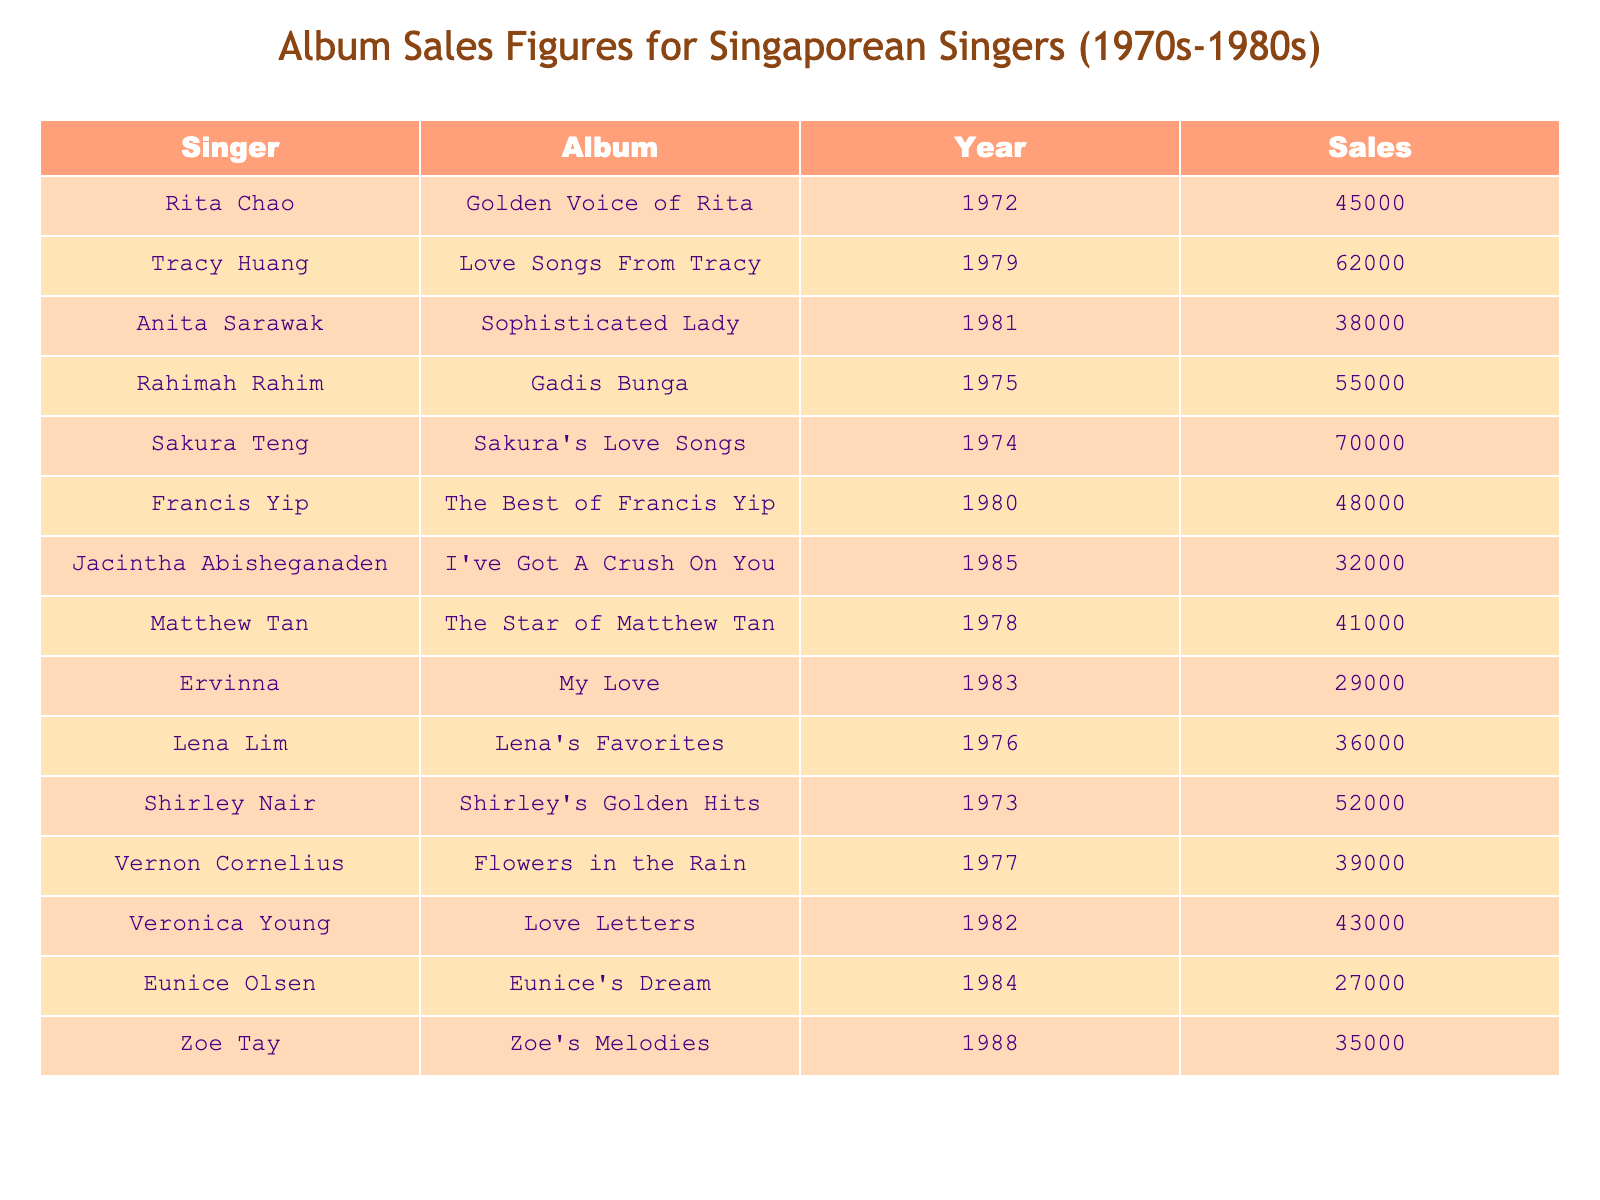What was the highest-selling album from the table? By scanning the sales figures provided in the table, I can see that "Sakura's Love Songs" by Sakura Teng has the highest sales figure of 70,000
Answer: 70,000 Which album had lower sales: "Golden Voice of Rita" or "Gadis Bunga"? Comparing the sales figures, "Golden Voice of Rita" sold 45,000 and "Gadis Bunga" sold 55,000. Since 45,000 < 55,000, the lower sales album is "Golden Voice of Rita."
Answer: "Golden Voice of Rita" How many albums were sold in total across all singers listed? Adding all the sales figures together: 45000 + 62000 + 38000 + 55000 + 70000 + 48000 + 32000 + 41000 + 29000 + 36000 + 52000 + 39000 + 43000 + 27000 + 35000 =  738000
Answer: 738000 Which singer had the lowest sales in their album? Looking at the sales figures, "My Love" by Ervinna has the lowest sales figure of 29,000
Answer: 29,000 Is there a singer who had an album sell more than 60,000 copies? Yes, by checking the sales figures, I can confirm that "Love Songs From Tracy" by Tracy Huang sold 62,000 copies and "Sakura's Love Songs" by Sakura Teng sold 70,000 copies.
Answer: Yes What is the average sales figure for albums released in the year 1984? In 1984, only one album was released, which is "Eunice's Dream" with sales of 27,000. Thus, the average sales figure is also 27,000 since there is just one album.
Answer: 27,000 How many more albums did Tracy Huang sell compared to Matthew Tan? Tracy Huang sold 62,000, while Matthew Tan sold 41,000. The difference is 62,000 - 41,000 = 21,000, meaning Tracy Huang sold 21,000 more albums than Matthew Tan.
Answer: 21,000 Which singer had their album released in 1981? Referring to the table, "Sophisticated Lady" by Anita Sarawak was released in 1981.
Answer: Anita Sarawak Which two singers had album sales figures that combined exceed 100,000? I can see that "Sakura's Love Songs" by Sakura Teng (70,000) and "Love Songs from Tracy" by Tracy Huang (62,000) combine to exceed 100,000. Their sum is 70,000 + 62,000 = 132,000.
Answer: Sakura Teng and Tracy Huang Was there any album released in 1976 that had sales above 40,000? The album "Lena's Favorites" released in 1976 had sales of 36,000, which is not above 40,000. Therefore, there was no album from that year with sales above 40,000.
Answer: No 